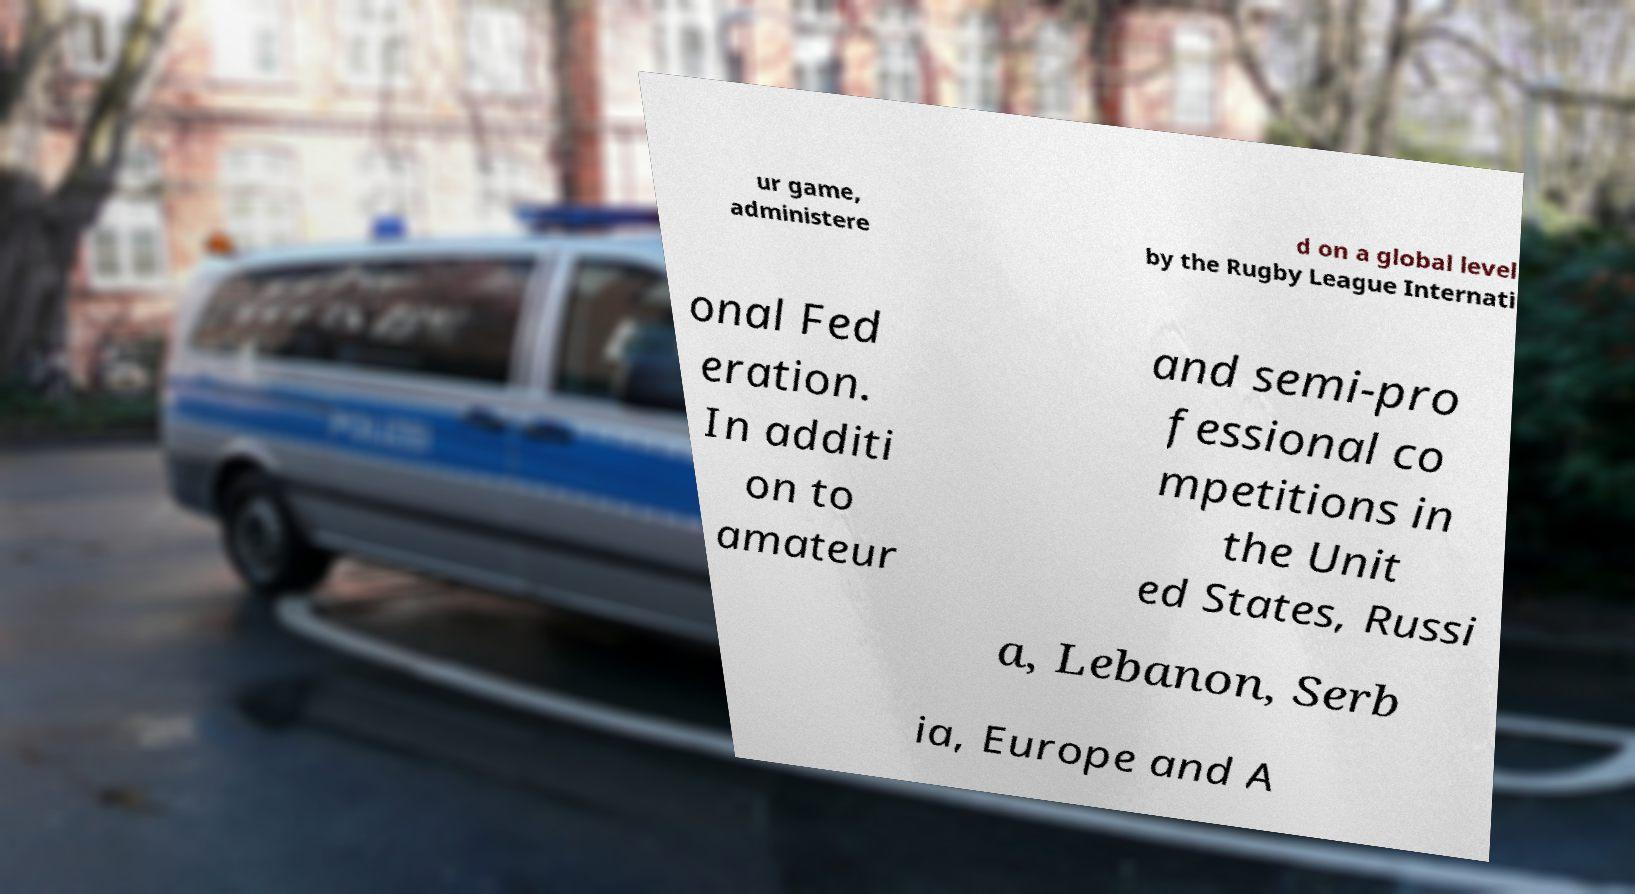Could you assist in decoding the text presented in this image and type it out clearly? ur game, administere d on a global level by the Rugby League Internati onal Fed eration. In additi on to amateur and semi-pro fessional co mpetitions in the Unit ed States, Russi a, Lebanon, Serb ia, Europe and A 